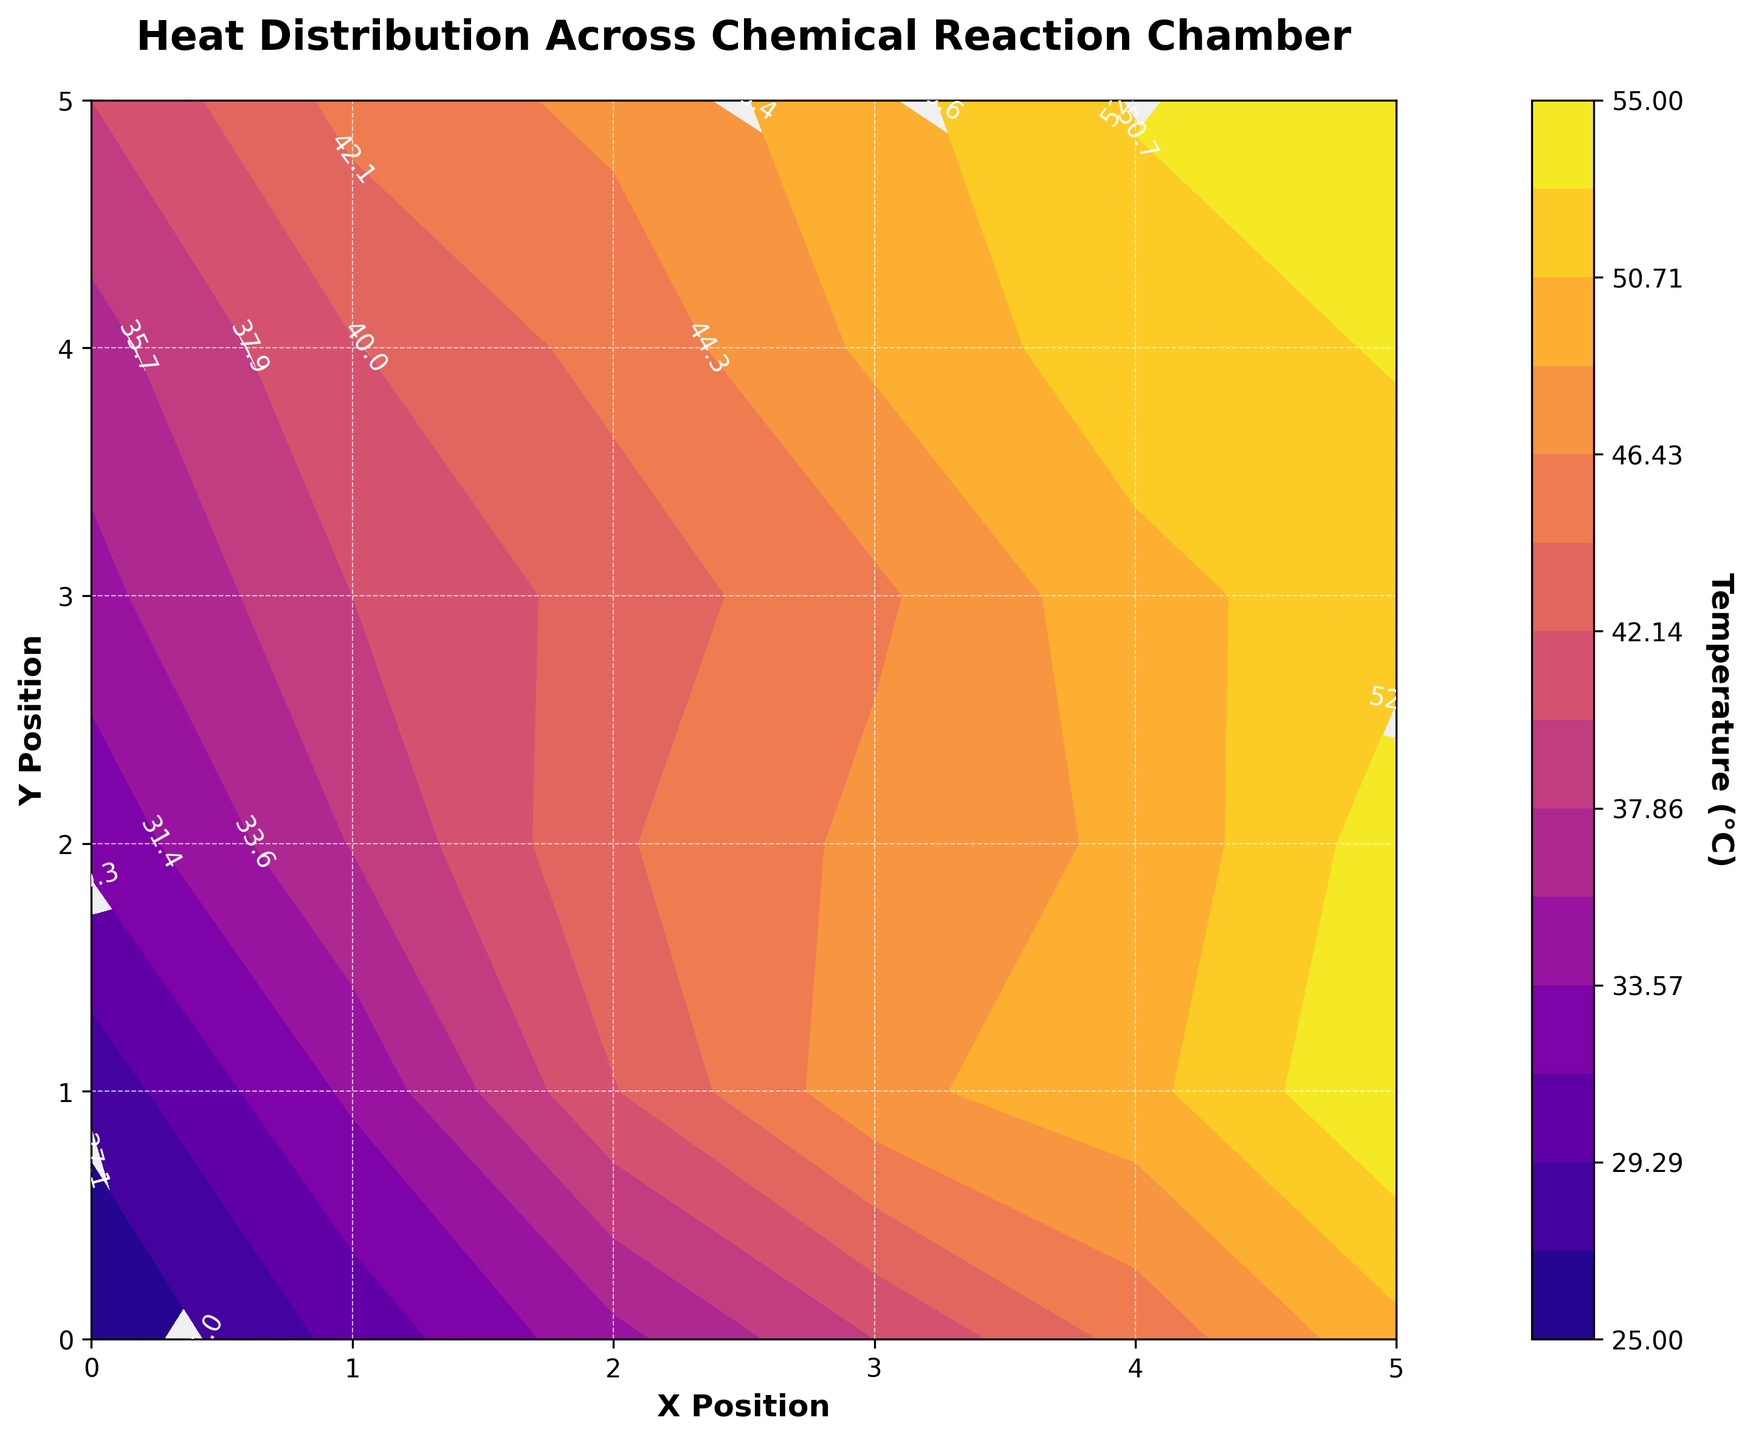What is the title of the plot? The title is usually displayed prominently at the top of the graph. Here, it reads "Heat Distribution Across Chemical Reaction Chamber"
Answer: Heat Distribution Across Chemical Reaction Chamber What are the labels of the x and y axes? These labels are typically found horizontally and vertically along the axes. Here, the x-axis is labeled "X Position" and the y-axis is labeled "Y Position".
Answer: X Position and Y Position What color scheme is used for the contour plot? The color scheme is mentioned as 'plasma', which typically has colors ranging from purple to yellow.
Answer: Plasma Which locations in the chamber have the highest temperatures? By observing the contour plot and the color intensity, the highest temperatures are represented by the brightest colors, usually occurring at the top right (5, 5).
Answer: Top right (5, 5) What is the temperature at position (2, 2)? You can find that the contour labels and color gradients indicate the temperature values at given positions; at (2, 2) the temperature is around 44°C
Answer: 44°C What is the difference in temperature between positions (0, 0) and (5, 5)? Position (0, 0) has a temperature of 25°C, and (5, 5) has 55°C. The difference is 55 - 25 = 30°C.
Answer: 30°C Which position has a higher temperature, (3, 3) or (4, 4)? (3, 3) shows 46°C while (4, 4) shows 52°C; compare the two values, 52°C is higher than 46°C.
Answer: (4, 4) How many contour levels are used in the plot? The plot uses levels to represent different temperature ranges; here, there are 15 levels used.
Answer: 15 What can you infer about the heat distribution pattern from the plot? The contour plot shows an increasing temperature from the bottom left to the top right, indicating heat spreads more towards the latter region.
Answer: Increasing towards top-right Is there a position where the temperature is 50°C? If so, where? By checking the contours labeled 50, we find it near positions (4, 1) and (4, 3).
Answer: Near (4, 1) and (4, 3) 